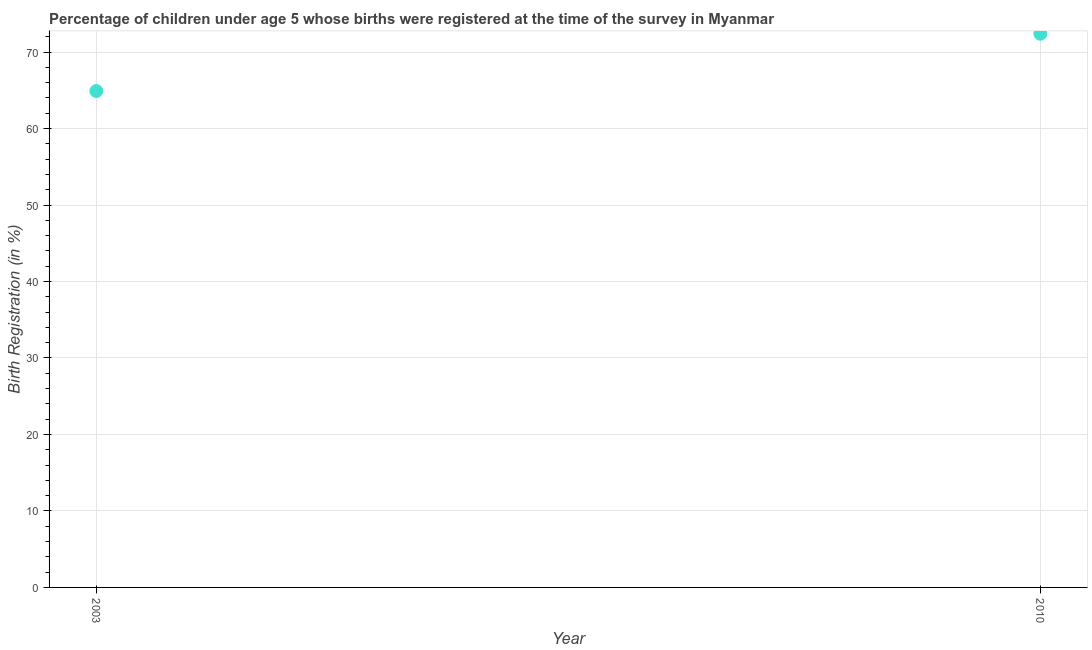What is the birth registration in 2010?
Make the answer very short. 72.4. Across all years, what is the maximum birth registration?
Keep it short and to the point. 72.4. Across all years, what is the minimum birth registration?
Your answer should be very brief. 64.9. In which year was the birth registration maximum?
Give a very brief answer. 2010. In which year was the birth registration minimum?
Your answer should be compact. 2003. What is the sum of the birth registration?
Offer a very short reply. 137.3. What is the difference between the birth registration in 2003 and 2010?
Keep it short and to the point. -7.5. What is the average birth registration per year?
Make the answer very short. 68.65. What is the median birth registration?
Offer a very short reply. 68.65. In how many years, is the birth registration greater than 56 %?
Keep it short and to the point. 2. What is the ratio of the birth registration in 2003 to that in 2010?
Your response must be concise. 0.9. In how many years, is the birth registration greater than the average birth registration taken over all years?
Give a very brief answer. 1. Does the birth registration monotonically increase over the years?
Make the answer very short. Yes. How many dotlines are there?
Provide a short and direct response. 1. Does the graph contain any zero values?
Give a very brief answer. No. Does the graph contain grids?
Your answer should be compact. Yes. What is the title of the graph?
Provide a short and direct response. Percentage of children under age 5 whose births were registered at the time of the survey in Myanmar. What is the label or title of the Y-axis?
Offer a very short reply. Birth Registration (in %). What is the Birth Registration (in %) in 2003?
Offer a very short reply. 64.9. What is the Birth Registration (in %) in 2010?
Ensure brevity in your answer.  72.4. What is the difference between the Birth Registration (in %) in 2003 and 2010?
Give a very brief answer. -7.5. What is the ratio of the Birth Registration (in %) in 2003 to that in 2010?
Your response must be concise. 0.9. 